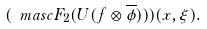<formula> <loc_0><loc_0><loc_500><loc_500>( \ m a s c F _ { 2 } ( U ( f \otimes \overline { \phi } ) ) ) ( x , \xi ) .</formula> 